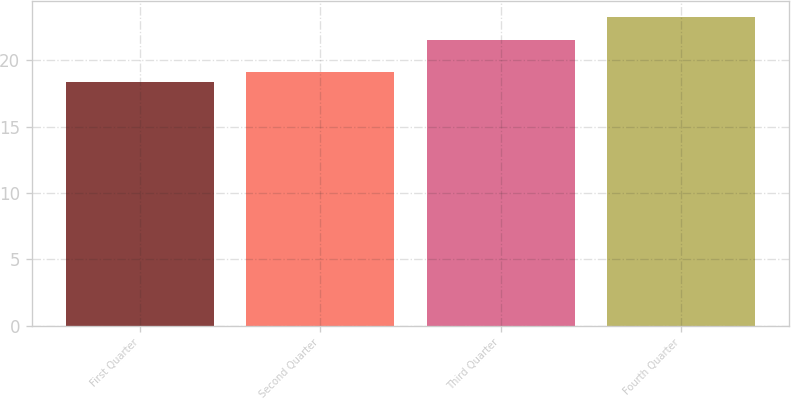Convert chart to OTSL. <chart><loc_0><loc_0><loc_500><loc_500><bar_chart><fcel>First Quarter<fcel>Second Quarter<fcel>Third Quarter<fcel>Fourth Quarter<nl><fcel>18.38<fcel>19.15<fcel>21.55<fcel>23.28<nl></chart> 